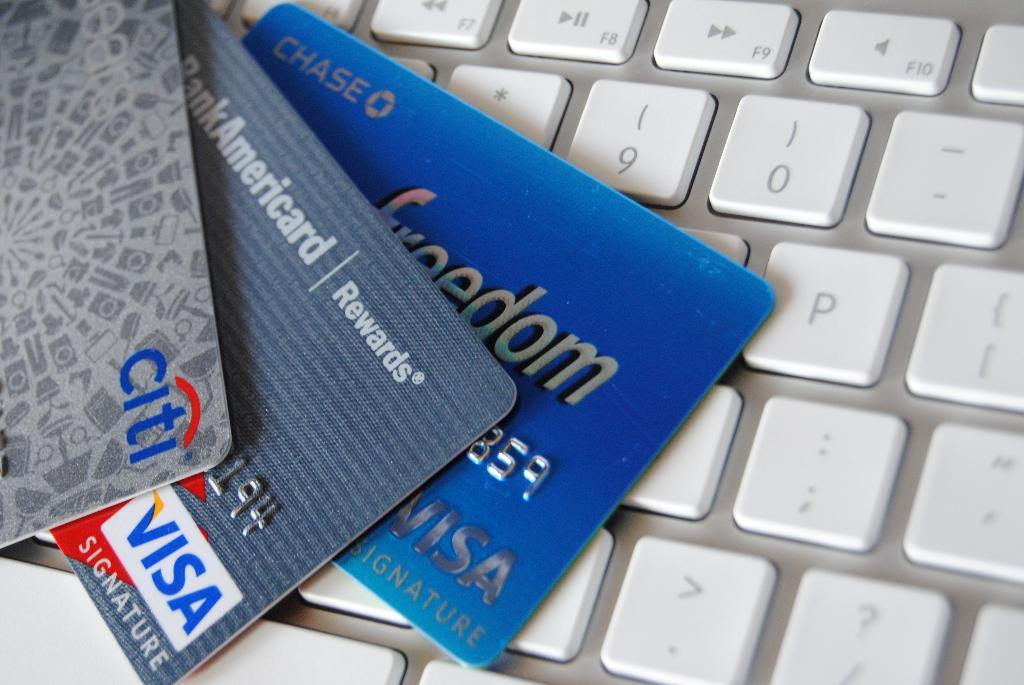Provide a one-sentence caption for the provided image. A citi bank and two visa cards are fanned out on a section of a keyboard. 